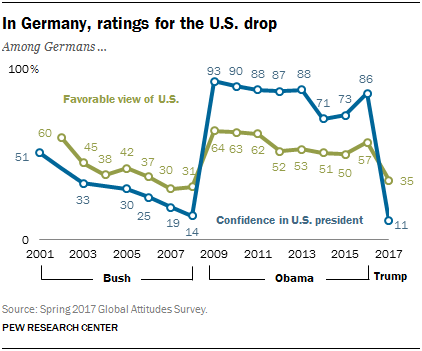Give some essential details in this illustration. The highest confidence rate was obtained in 2009. The sum of the years' confidence rate obtained between 2001 and 2003 is 84%. 